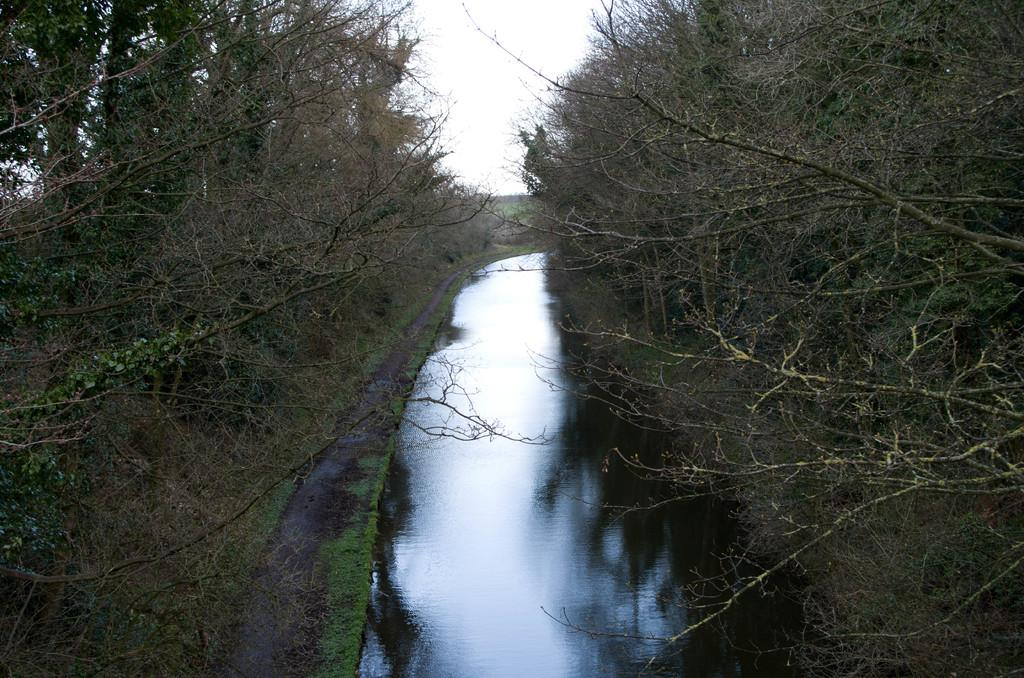What is located in the middle of the image? There is water in the middle of the image. What type of vegetation can be seen on either side of the image? There are trees on either side of the image. What is visible at the top of the image? The sky is visible at the top of the image. What type of pot is hidden behind the trees in the image? There is no pot present in the image; it only features water, trees, and the sky. 